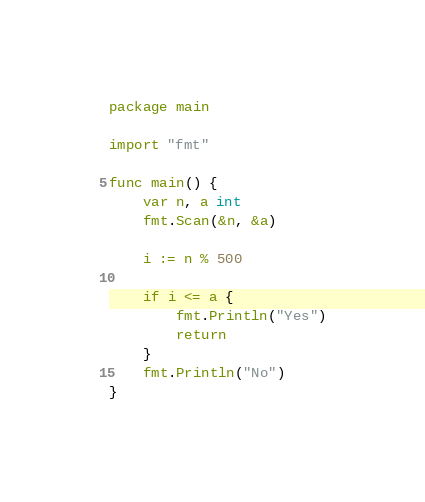Convert code to text. <code><loc_0><loc_0><loc_500><loc_500><_Go_>package main

import "fmt"

func main() {
	var n, a int
	fmt.Scan(&n, &a)

	i := n % 500

	if i <= a {
		fmt.Println("Yes")
		return
	}
	fmt.Println("No")
}
</code> 